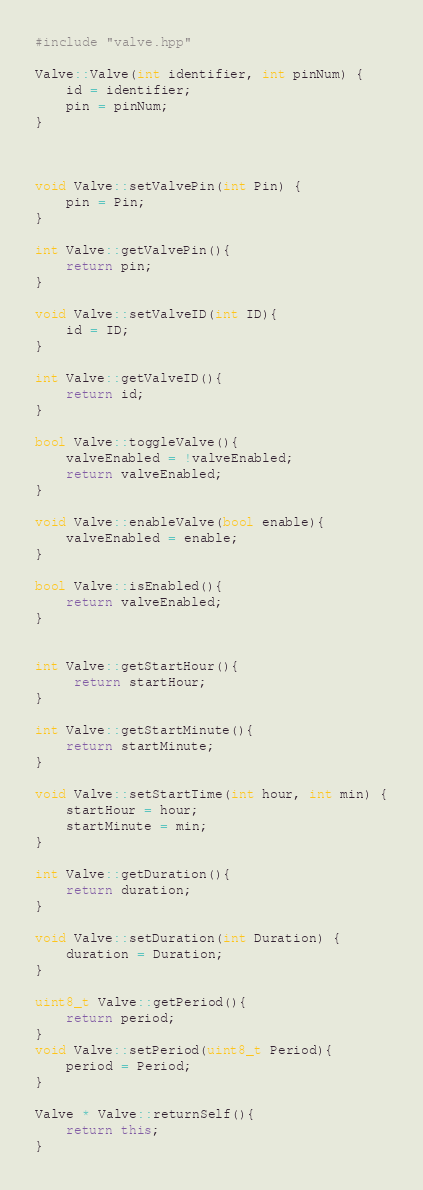Convert code to text. <code><loc_0><loc_0><loc_500><loc_500><_C++_>#include "valve.hpp"

Valve::Valve(int identifier, int pinNum) {
    id = identifier;
    pin = pinNum;
}



void Valve::setValvePin(int Pin) {
    pin = Pin;
}

int Valve::getValvePin(){
    return pin;
}

void Valve::setValveID(int ID){
    id = ID;
}

int Valve::getValveID(){
    return id;
}

bool Valve::toggleValve(){
    valveEnabled = !valveEnabled;
    return valveEnabled;
}

void Valve::enableValve(bool enable){
    valveEnabled = enable;
}

bool Valve::isEnabled(){
    return valveEnabled;
}


int Valve::getStartHour(){
     return startHour;
}

int Valve::getStartMinute(){
    return startMinute;
}

void Valve::setStartTime(int hour, int min) {
    startHour = hour;
    startMinute = min;
}

int Valve::getDuration(){
    return duration;
}

void Valve::setDuration(int Duration) {
    duration = Duration;
}

uint8_t Valve::getPeriod(){
    return period;
}
void Valve::setPeriod(uint8_t Period){
    period = Period;
}

Valve * Valve::returnSelf(){
    return this;
}</code> 